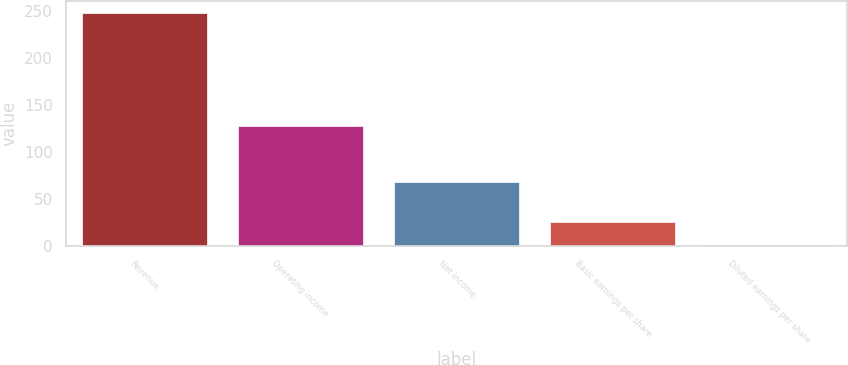Convert chart. <chart><loc_0><loc_0><loc_500><loc_500><bar_chart><fcel>Revenue<fcel>Operating income<fcel>Net income<fcel>Basic earnings per share<fcel>Diluted earnings per share<nl><fcel>248.3<fcel>127.4<fcel>67.8<fcel>25.22<fcel>0.43<nl></chart> 